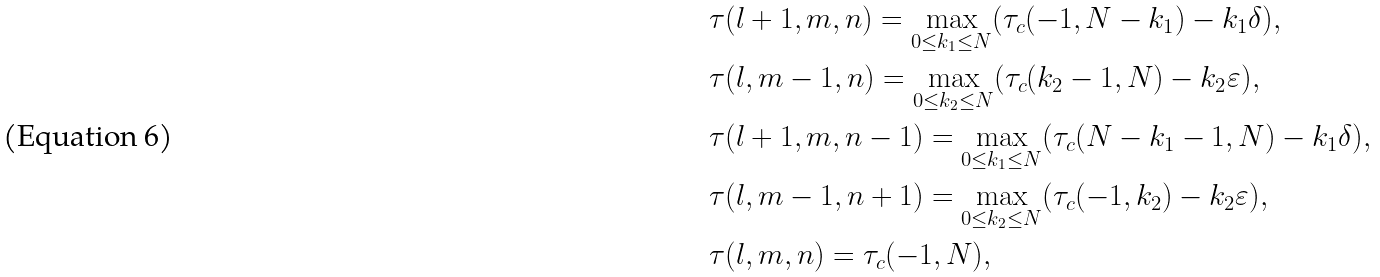Convert formula to latex. <formula><loc_0><loc_0><loc_500><loc_500>& \tau ( l + 1 , m , n ) = \max _ { 0 \leq k _ { 1 } \leq N } ( \tau _ { c } ( - 1 , N - k _ { 1 } ) - k _ { 1 } \delta ) , \\ & \tau ( l , m - 1 , n ) = \max _ { 0 \leq k _ { 2 } \leq N } ( \tau _ { c } ( k _ { 2 } - 1 , N ) - k _ { 2 } \varepsilon ) , \\ & \tau ( l + 1 , m , n - 1 ) = \max _ { 0 \leq k _ { 1 } \leq N } ( \tau _ { c } ( N - k _ { 1 } - 1 , N ) - k _ { 1 } \delta ) , \\ & \tau ( l , m - 1 , n + 1 ) = \max _ { 0 \leq k _ { 2 } \leq N } ( \tau _ { c } ( - 1 , k _ { 2 } ) - k _ { 2 } \varepsilon ) , \\ & \tau ( l , m , n ) = \tau _ { c } ( - 1 , N ) ,</formula> 